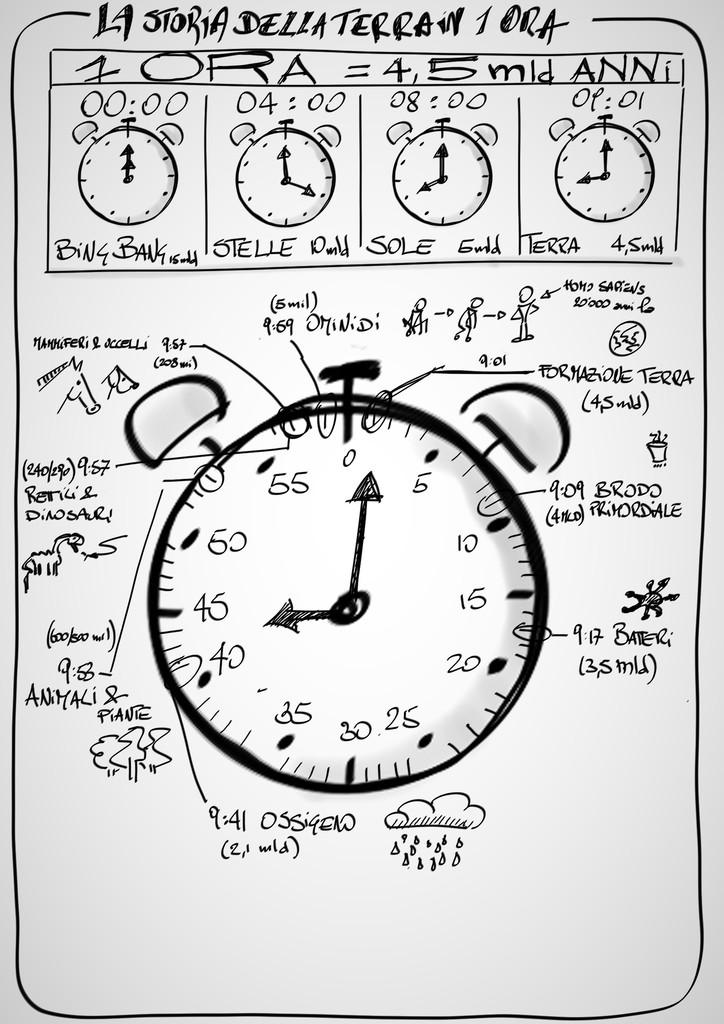<image>
Create a compact narrative representing the image presented. A drawing of an alarm clock which is roughly pointing 9:01. 